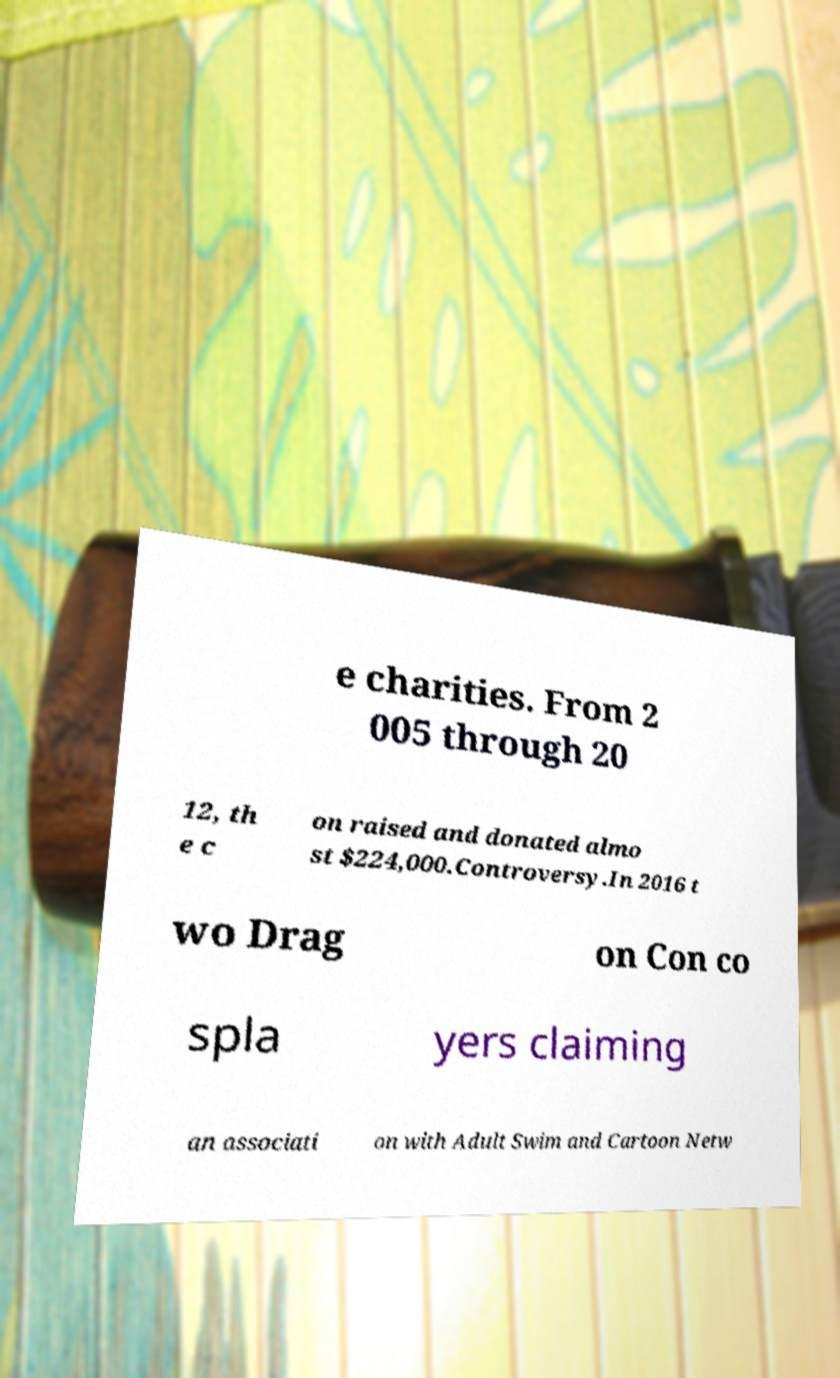Could you extract and type out the text from this image? e charities. From 2 005 through 20 12, th e c on raised and donated almo st $224,000.Controversy.In 2016 t wo Drag on Con co spla yers claiming an associati on with Adult Swim and Cartoon Netw 